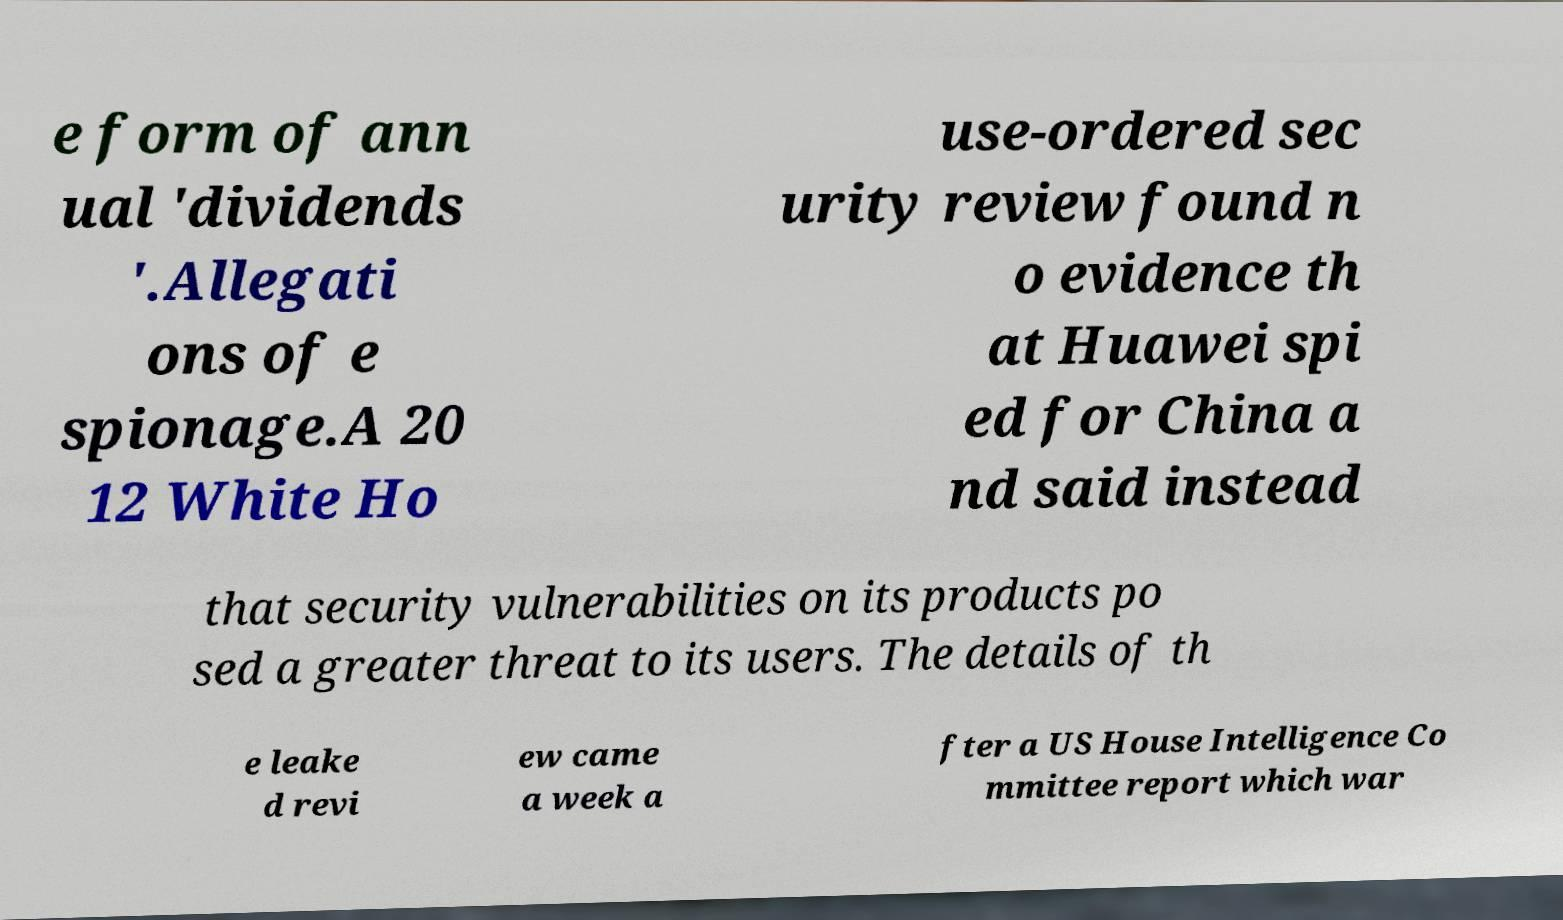Can you accurately transcribe the text from the provided image for me? e form of ann ual 'dividends '.Allegati ons of e spionage.A 20 12 White Ho use-ordered sec urity review found n o evidence th at Huawei spi ed for China a nd said instead that security vulnerabilities on its products po sed a greater threat to its users. The details of th e leake d revi ew came a week a fter a US House Intelligence Co mmittee report which war 